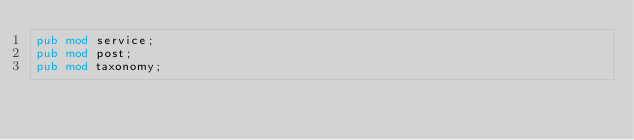<code> <loc_0><loc_0><loc_500><loc_500><_Rust_>pub mod service;
pub mod post;
pub mod taxonomy;
</code> 